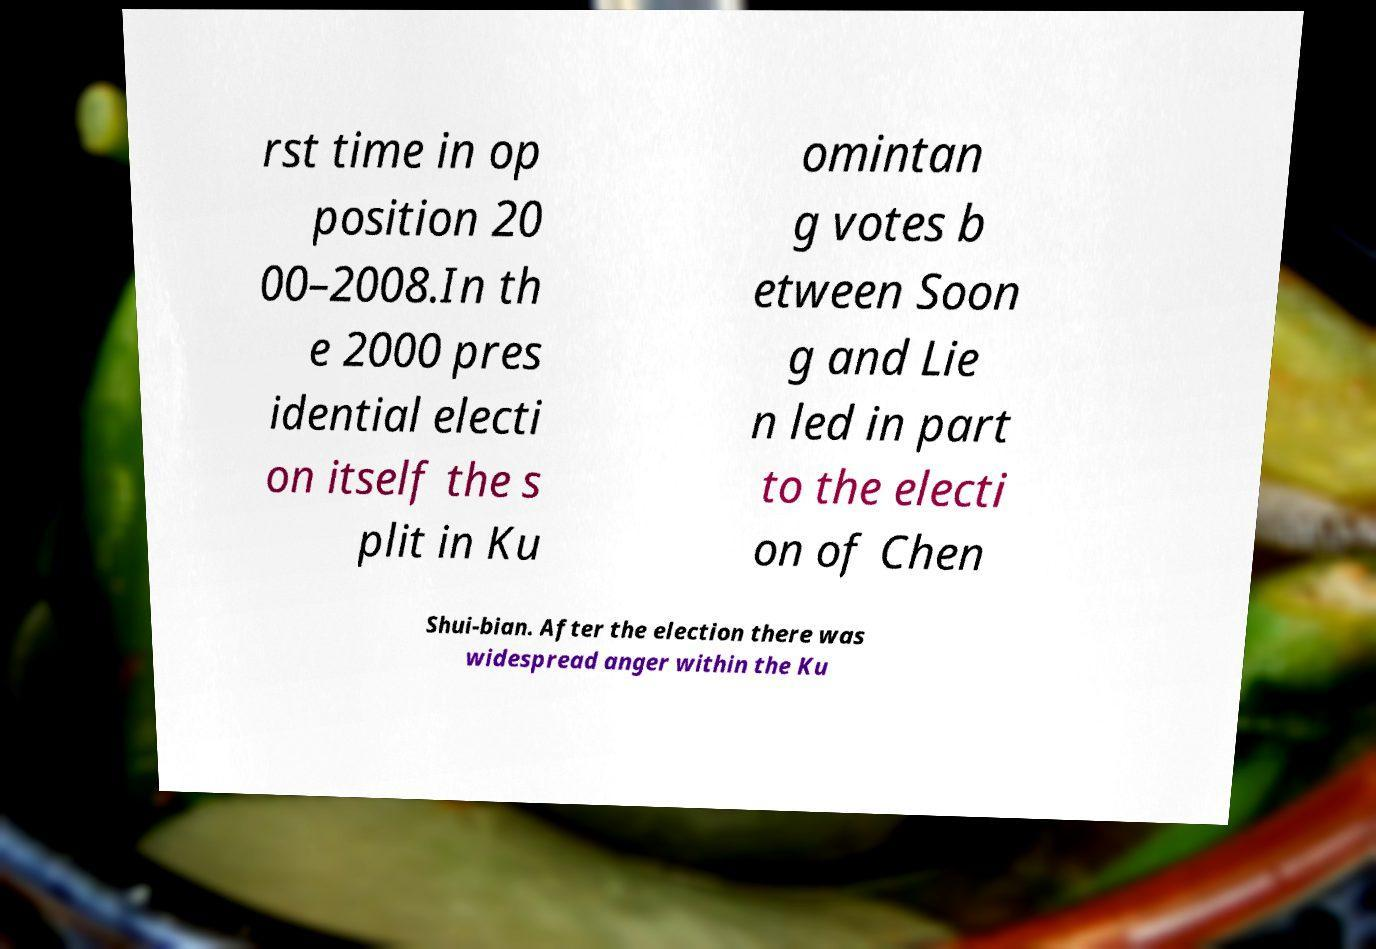For documentation purposes, I need the text within this image transcribed. Could you provide that? rst time in op position 20 00–2008.In th e 2000 pres idential electi on itself the s plit in Ku omintan g votes b etween Soon g and Lie n led in part to the electi on of Chen Shui-bian. After the election there was widespread anger within the Ku 